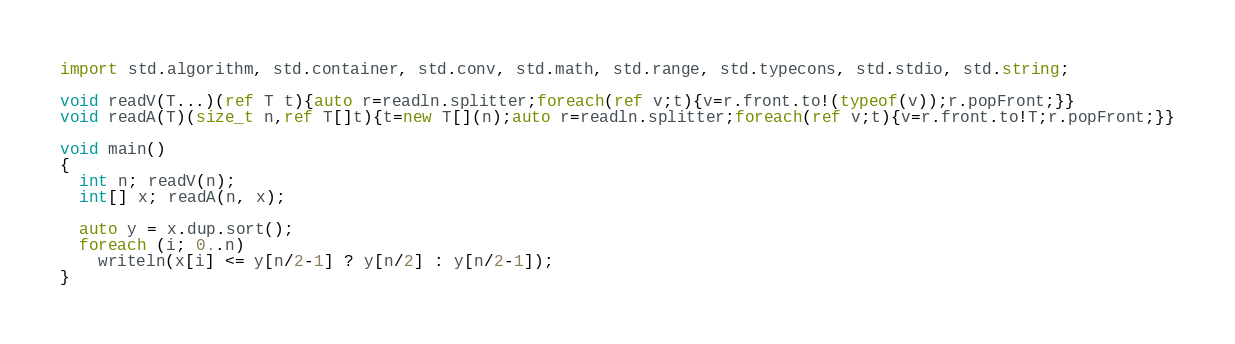Convert code to text. <code><loc_0><loc_0><loc_500><loc_500><_D_>import std.algorithm, std.container, std.conv, std.math, std.range, std.typecons, std.stdio, std.string;

void readV(T...)(ref T t){auto r=readln.splitter;foreach(ref v;t){v=r.front.to!(typeof(v));r.popFront;}}
void readA(T)(size_t n,ref T[]t){t=new T[](n);auto r=readln.splitter;foreach(ref v;t){v=r.front.to!T;r.popFront;}}

void main()
{
  int n; readV(n);
  int[] x; readA(n, x);

  auto y = x.dup.sort();
  foreach (i; 0..n)
    writeln(x[i] <= y[n/2-1] ? y[n/2] : y[n/2-1]);
}
</code> 